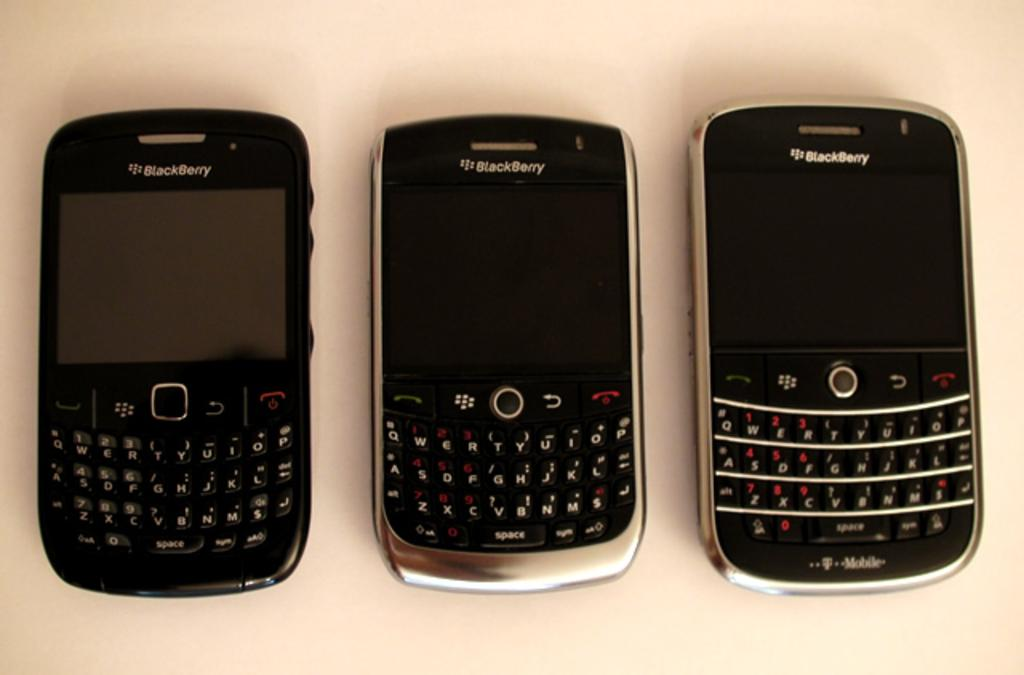<image>
Share a concise interpretation of the image provided. Three different models of Blackberry phones are laying side by side. 